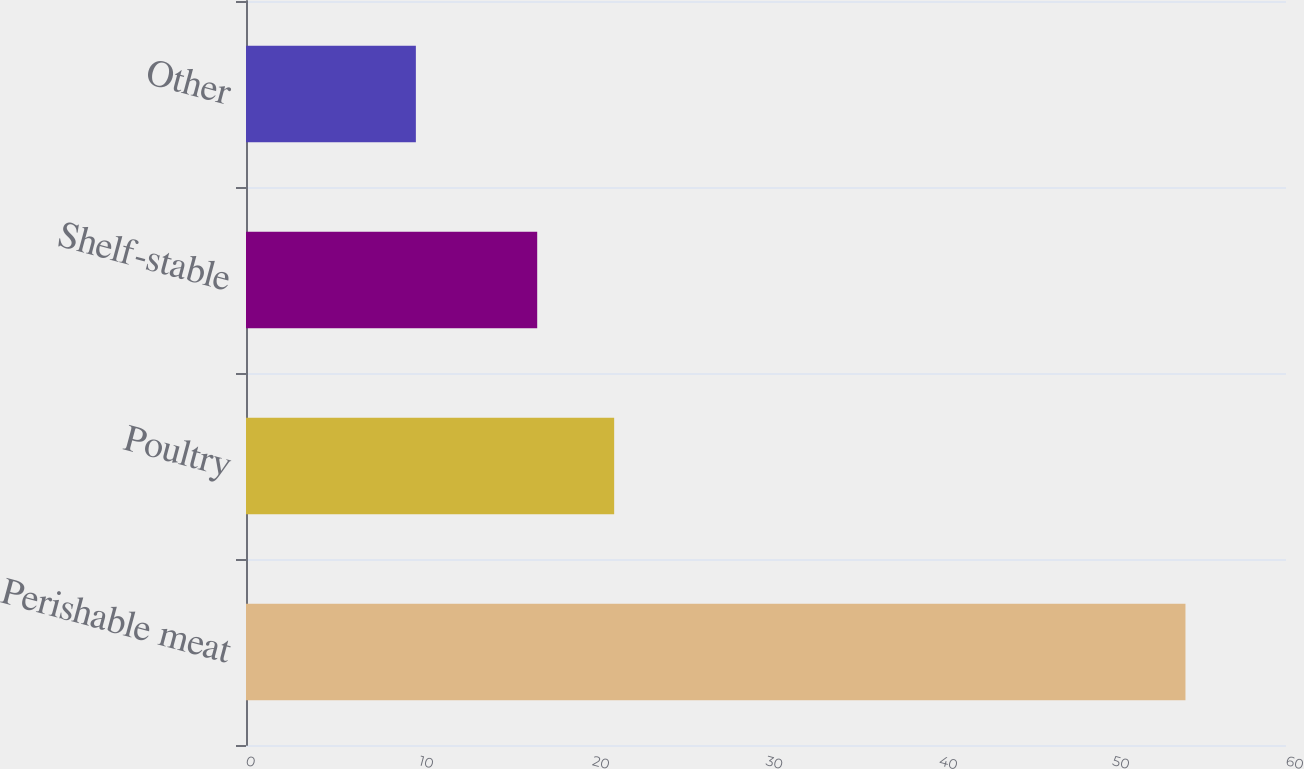<chart> <loc_0><loc_0><loc_500><loc_500><bar_chart><fcel>Perishable meat<fcel>Poultry<fcel>Shelf-stable<fcel>Other<nl><fcel>54.2<fcel>21.24<fcel>16.8<fcel>9.8<nl></chart> 